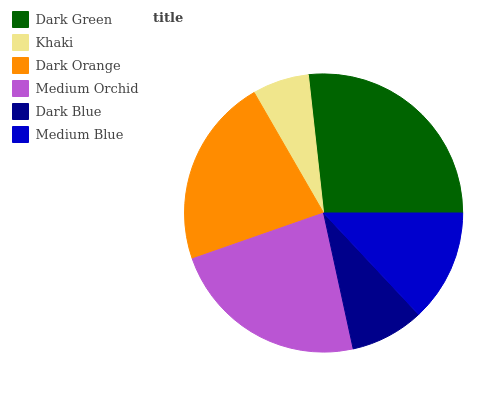Is Khaki the minimum?
Answer yes or no. Yes. Is Dark Green the maximum?
Answer yes or no. Yes. Is Dark Orange the minimum?
Answer yes or no. No. Is Dark Orange the maximum?
Answer yes or no. No. Is Dark Orange greater than Khaki?
Answer yes or no. Yes. Is Khaki less than Dark Orange?
Answer yes or no. Yes. Is Khaki greater than Dark Orange?
Answer yes or no. No. Is Dark Orange less than Khaki?
Answer yes or no. No. Is Dark Orange the high median?
Answer yes or no. Yes. Is Medium Blue the low median?
Answer yes or no. Yes. Is Medium Orchid the high median?
Answer yes or no. No. Is Medium Orchid the low median?
Answer yes or no. No. 